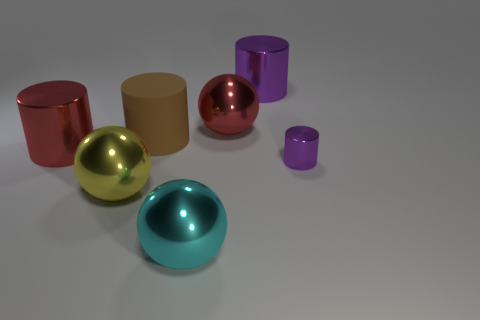There is a rubber cylinder that is the same size as the yellow metallic sphere; what color is it?
Provide a succinct answer. Brown. What number of objects are shiny balls on the right side of the yellow metallic object or big yellow balls?
Your answer should be compact. 3. How many other objects are the same size as the red metallic sphere?
Give a very brief answer. 5. There is a purple object in front of the big brown object; what size is it?
Make the answer very short. Small. What shape is the big yellow thing that is made of the same material as the small cylinder?
Your answer should be very brief. Sphere. Are there any other things of the same color as the small metallic cylinder?
Offer a very short reply. Yes. What color is the shiny cylinder behind the red object that is left of the brown object?
Your answer should be very brief. Purple. How many large things are green metallic balls or cylinders?
Provide a succinct answer. 3. There is a brown thing that is the same shape as the small purple object; what is it made of?
Offer a very short reply. Rubber. Is there anything else that is made of the same material as the red cylinder?
Ensure brevity in your answer.  Yes. 